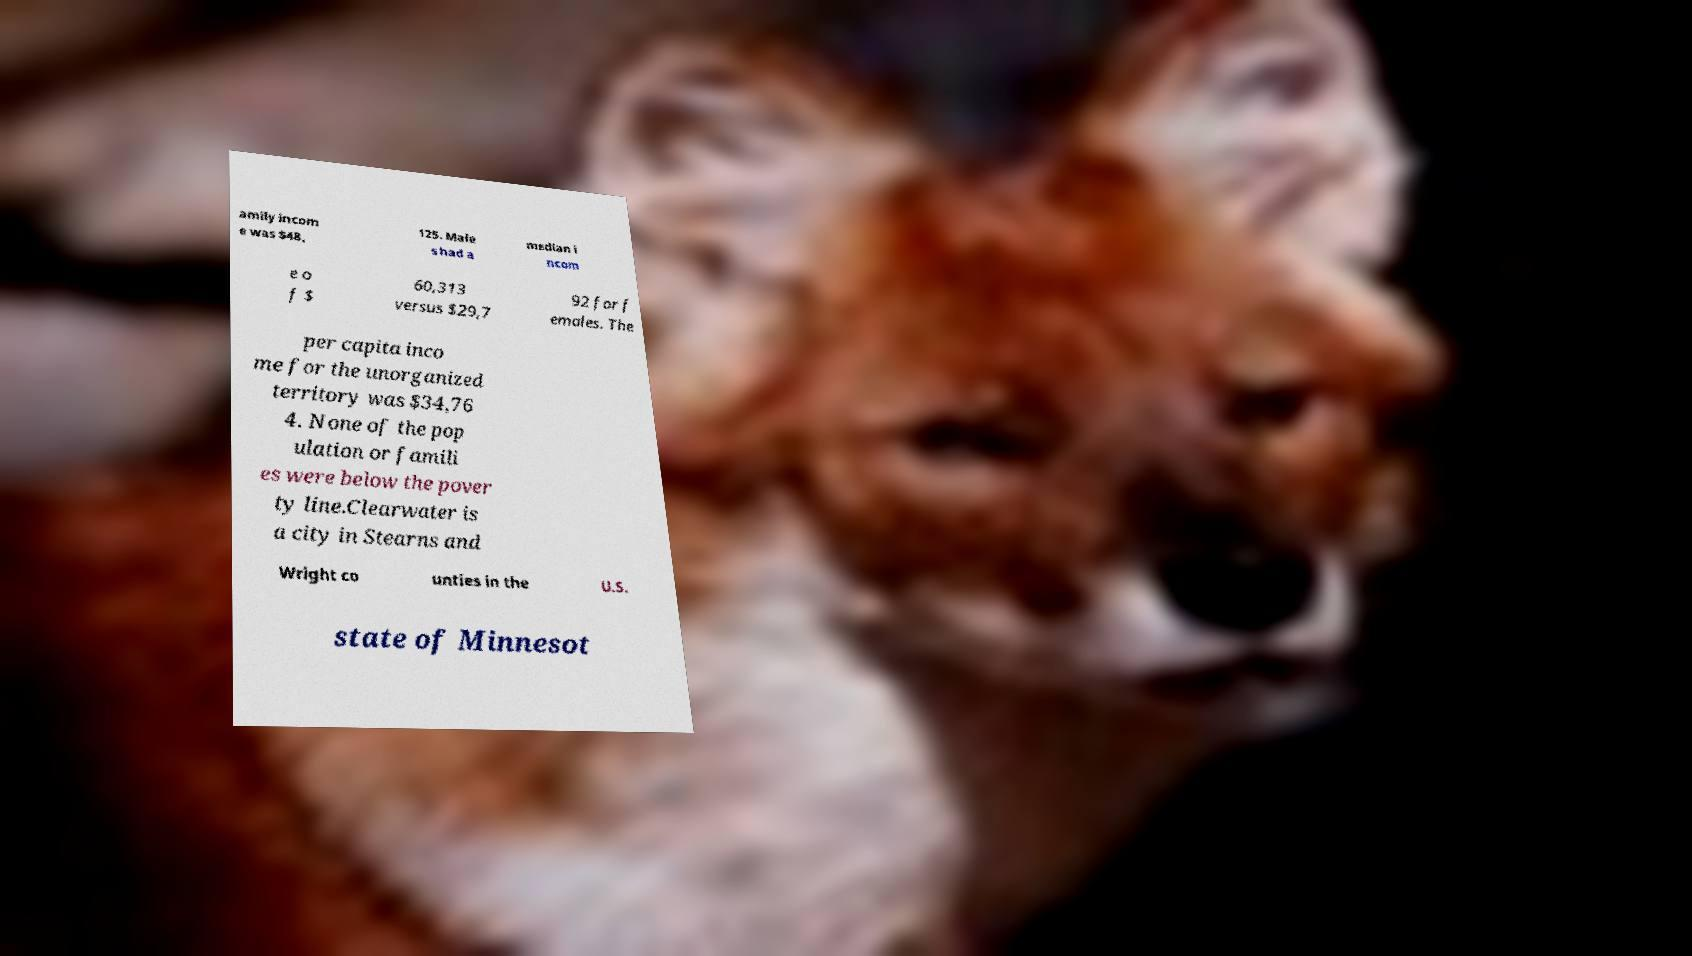Could you assist in decoding the text presented in this image and type it out clearly? amily incom e was $48, 125. Male s had a median i ncom e o f $ 60,313 versus $29,7 92 for f emales. The per capita inco me for the unorganized territory was $34,76 4. None of the pop ulation or famili es were below the pover ty line.Clearwater is a city in Stearns and Wright co unties in the U.S. state of Minnesot 